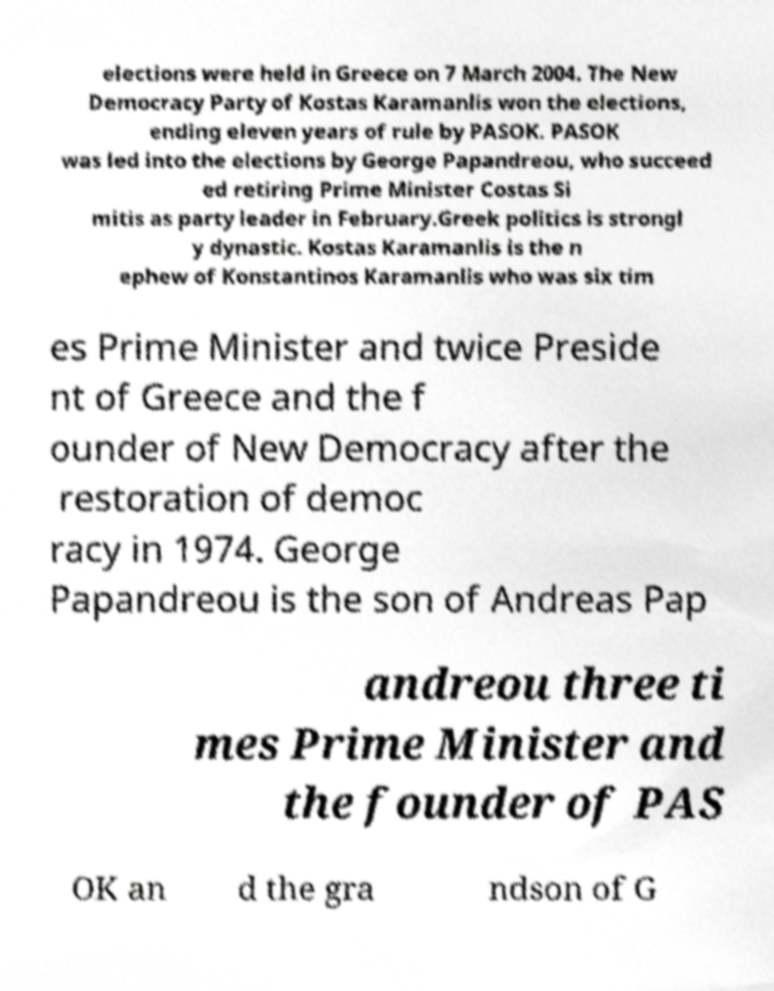Can you accurately transcribe the text from the provided image for me? elections were held in Greece on 7 March 2004. The New Democracy Party of Kostas Karamanlis won the elections, ending eleven years of rule by PASOK. PASOK was led into the elections by George Papandreou, who succeed ed retiring Prime Minister Costas Si mitis as party leader in February.Greek politics is strongl y dynastic. Kostas Karamanlis is the n ephew of Konstantinos Karamanlis who was six tim es Prime Minister and twice Preside nt of Greece and the f ounder of New Democracy after the restoration of democ racy in 1974. George Papandreou is the son of Andreas Pap andreou three ti mes Prime Minister and the founder of PAS OK an d the gra ndson of G 